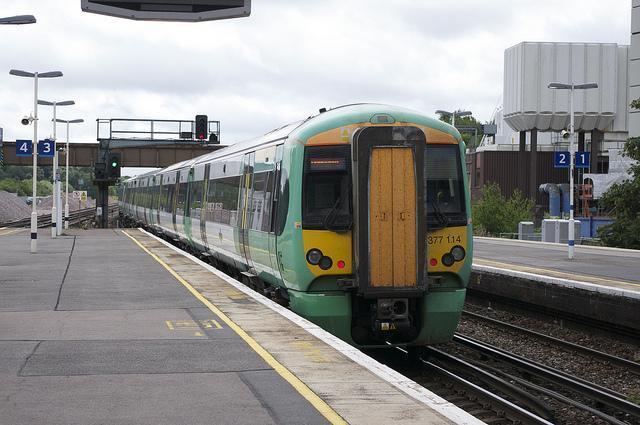How many trains are in the photo?
Give a very brief answer. 1. How many trains are in the picture?
Give a very brief answer. 1. 